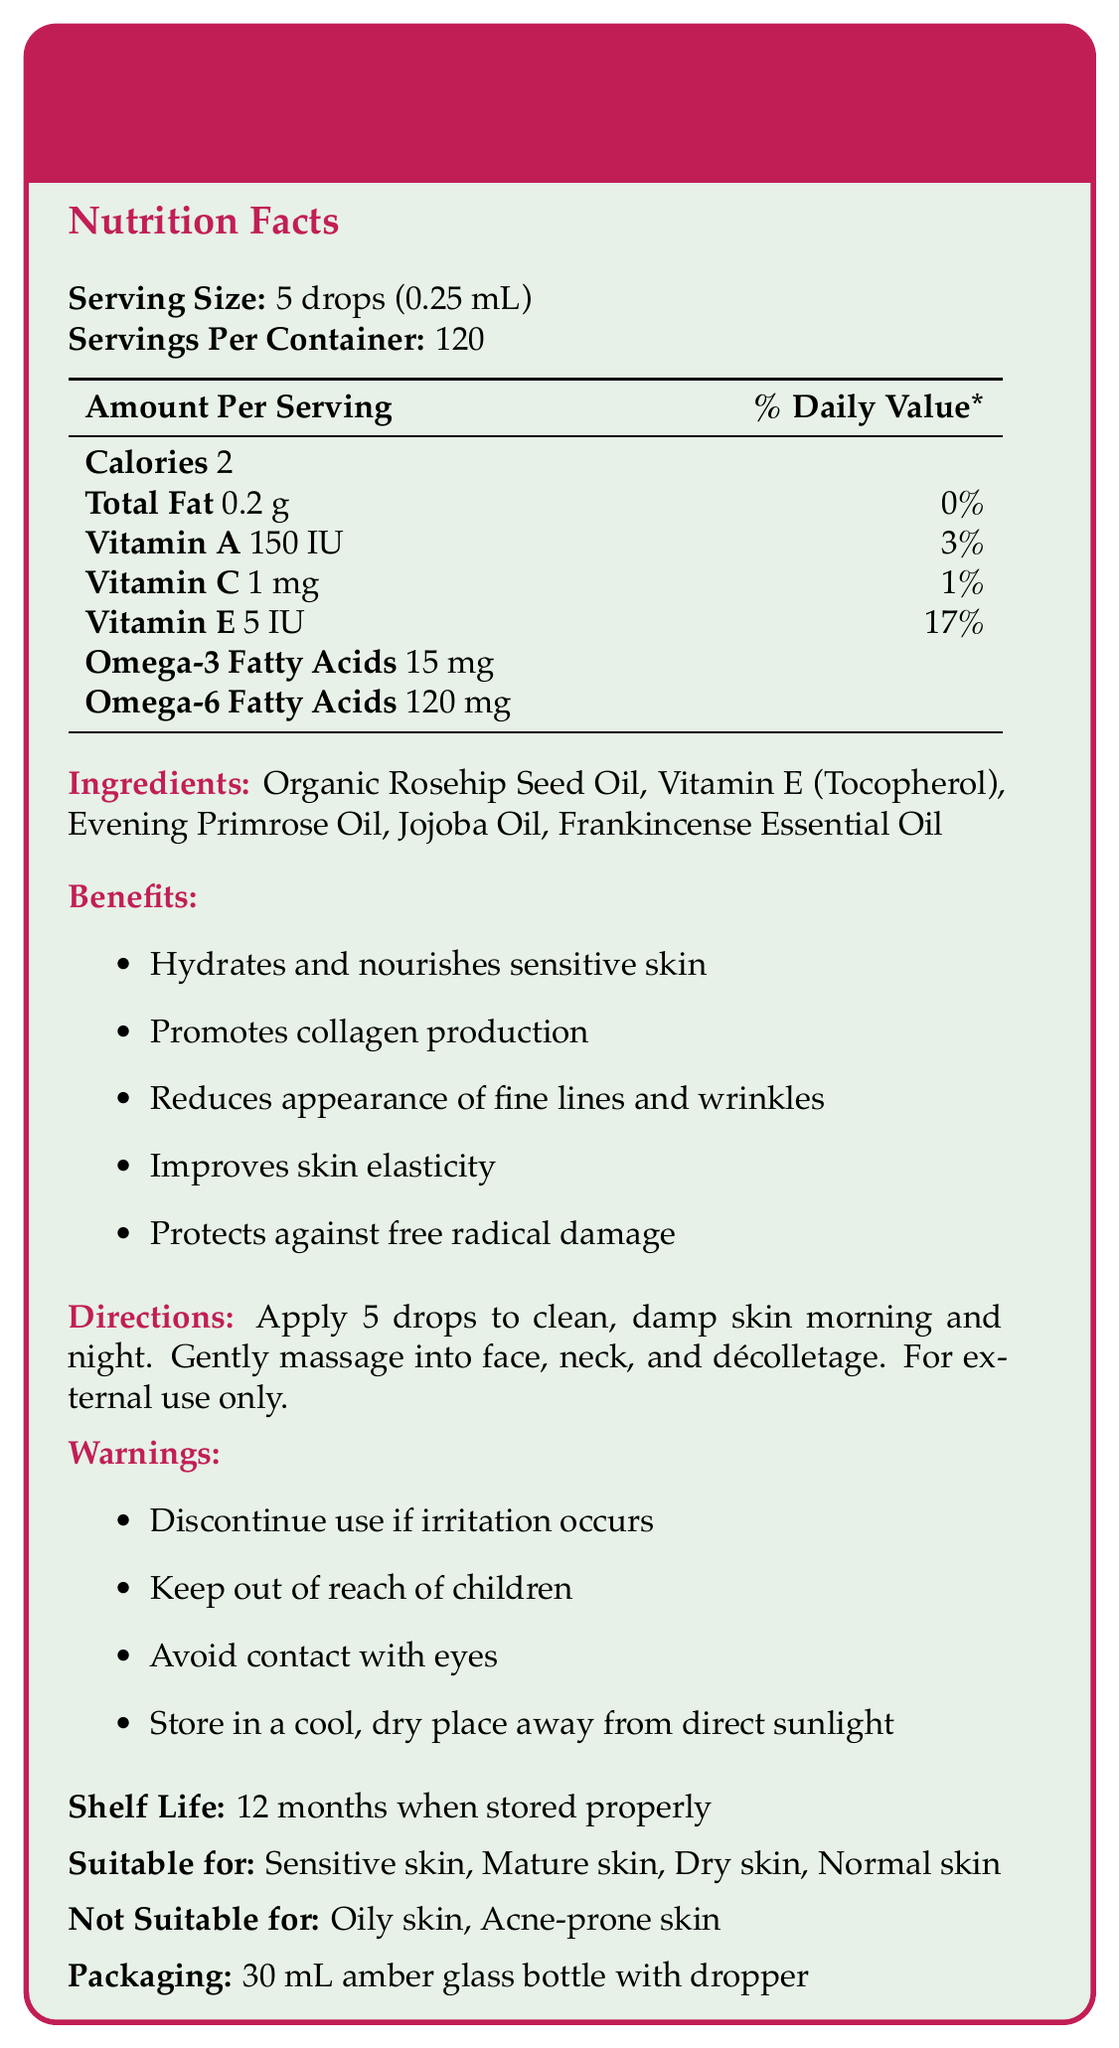what is the serving size of the serum? The document specifies that the serving size is 5 drops, which is equivalent to 0.25 mL.
Answer: 5 drops (0.25 mL) how many servings are there per container? The document states that there are 120 servings per container.
Answer: 120 what are the main ingredients of the serum? The ingredients are listed under the "Ingredients" section of the document.
Answer: Organic Rosehip Seed Oil, Vitamin E (Tocopherol), Evening Primrose Oil, Jojoba Oil, Frankincense Essential Oil how many calories are in one serving of the serum? The document mentions that there are 2 calories per serving.
Answer: 2 what is the percentage of the daily value of Vitamin E per serving? According to the document, each serving provides 17% of the daily value of Vitamin E.
Answer: 17% which of the following oils is not listed as an ingredient in the serum? A. Rosehip Seed Oil B. Coconut Oil C. Jojoba Oil The document lists Organic Rosehip Seed Oil, Jojoba Oil, Vitamin E, Evening Primrose Oil, and Frankincense Essential Oil, but not Coconut Oil.
Answer: B. Coconut Oil which vitamin has the highest percentage of daily value per serving? I. Vitamin A II. Vitamin C III. Vitamin E The document shows that Vitamin E has a daily value of 17%, which is higher compared to Vitamin A (3%) and Vitamin C (1%).
Answer: III. Vitamin E can this serum be used by people with oily skin? The document indicates that the serum is not suitable for oily skin.
Answer: No does the serum improve skin elasticity? The document lists "improves skin elasticity" as one of the benefits of the serum.
Answer: Yes describe the main idea of the document The document's main idea is to inform readers about the features and benefits of the Nourishing Rosehip & Vitamin E Serum, highlighting its natural composition and suitability for sensitive skin.
Answer: The document provides detailed information about the Nourishing Rosehip & Vitamin E Serum, including its ingredients, nutritional facts, benefits, usage directions, warnings, shelf life, suitability for different skin types, and packaging. It emphasizes the serum's natural ingredients and benefits for sensitive and mature skin. is there information on the manufacturing date of the serum? The document does not provide any details regarding the manufacturing date of the serum.
Answer: Not enough information what is the ideal storage condition for the serum? The document suggests storing the serum in a cool, dry place away from direct sunlight to maintain its shelf life for 12 months.
Answer: Store in a cool, dry place away from direct sunlight what are the benefits of using this serum? The document lists these specific benefits in the "Benefits" section.
Answer: Hydrates and nourishes sensitive skin, promotes collagen production, reduces appearance of fine lines and wrinkles, improves skin elasticity, protects against free radical damage how much Omega-6 fatty acids are there in one serving of the serum? One serving contains 120 mg of Omega-6 fatty acids, as stated in the nutrient info section of the document.
Answer: 120 mg what is the shelf life of the serum? The document mentions that the shelf life of the serum is 12 months when stored in cool, dry conditions away from sunlight.
Answer: 12 months when stored properly does the serum contain any preservatives? The ingredients listed in the document do not include any preservatives, only natural oils and essential oils.
Answer: No 